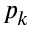<formula> <loc_0><loc_0><loc_500><loc_500>p _ { k }</formula> 